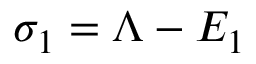<formula> <loc_0><loc_0><loc_500><loc_500>\sigma _ { 1 } = \Lambda - E _ { 1 }</formula> 